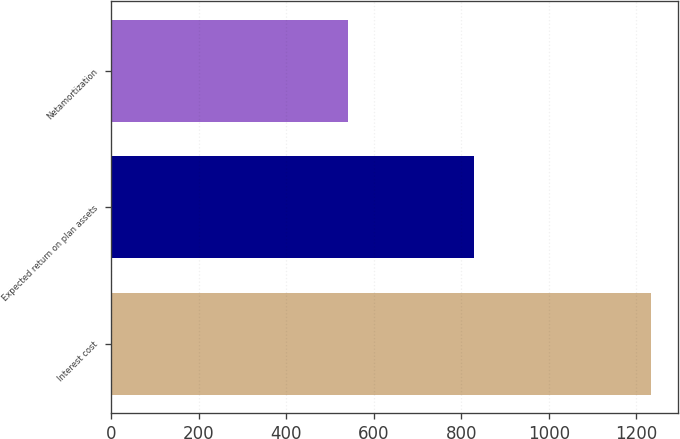Convert chart. <chart><loc_0><loc_0><loc_500><loc_500><bar_chart><fcel>Interest cost<fcel>Expected return on plan assets<fcel>Netamortization<nl><fcel>1235<fcel>829<fcel>540<nl></chart> 